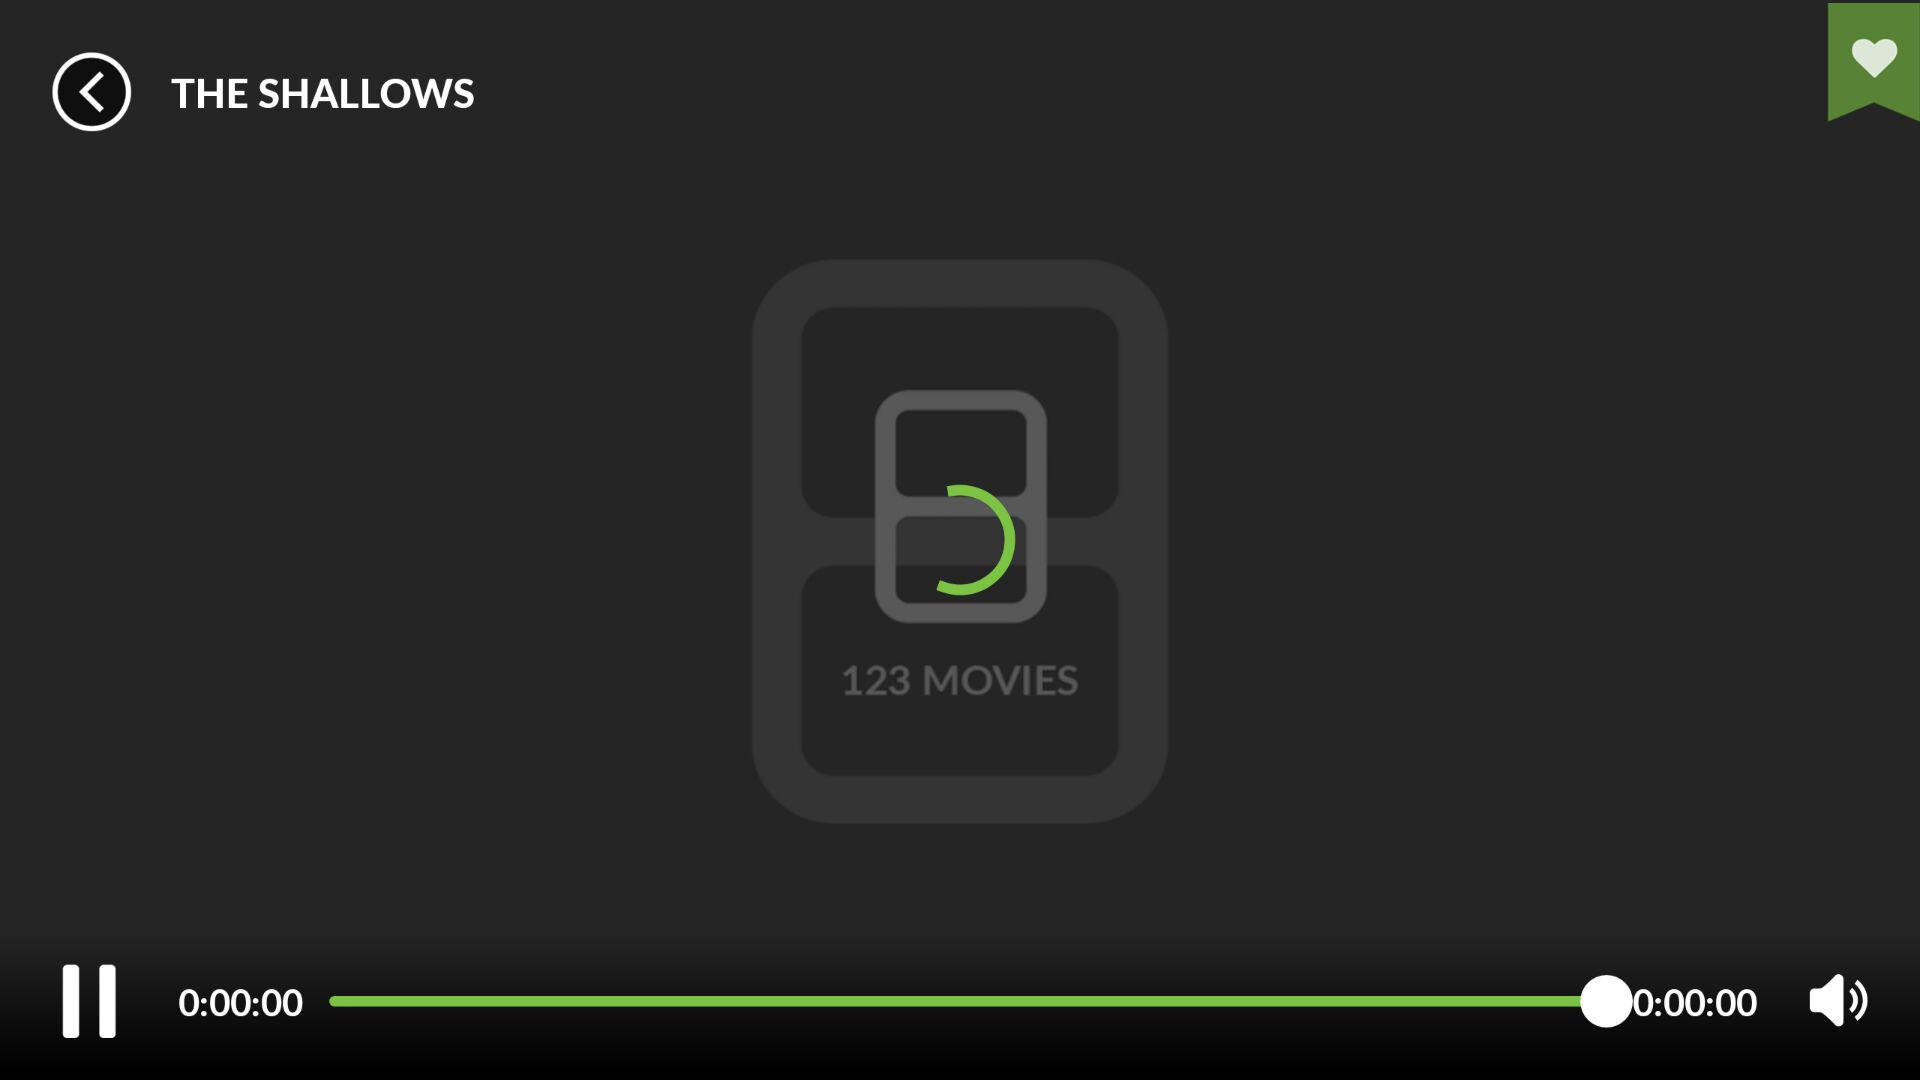What is the volume level of the video?
When the provided information is insufficient, respond with <no answer>. <no answer> 